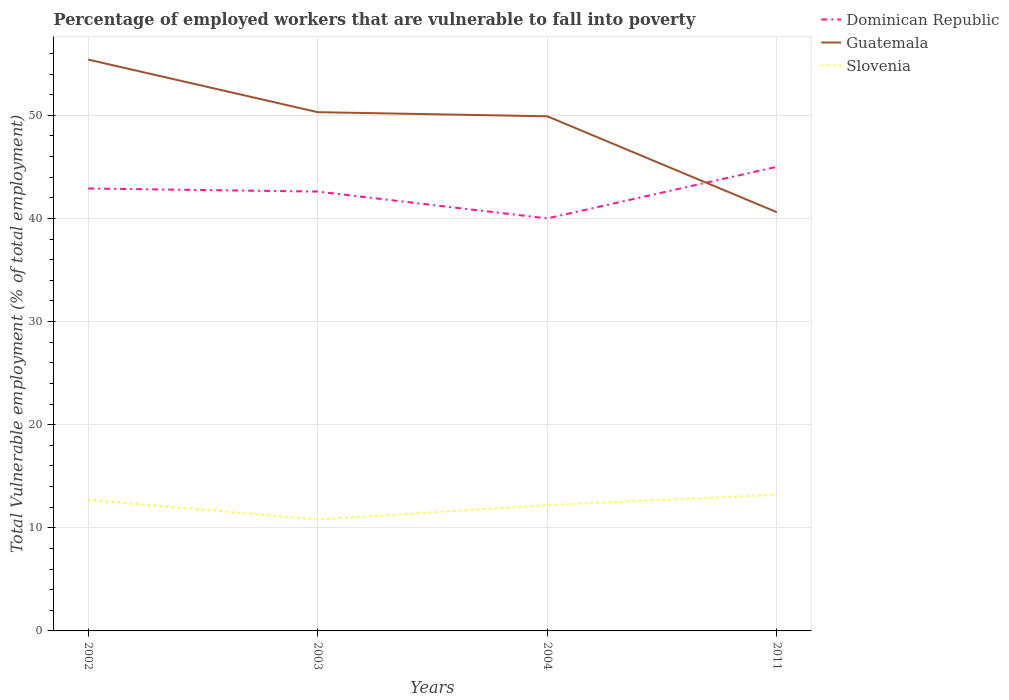Does the line corresponding to Slovenia intersect with the line corresponding to Guatemala?
Give a very brief answer. No. Is the number of lines equal to the number of legend labels?
Provide a succinct answer. Yes. Across all years, what is the maximum percentage of employed workers who are vulnerable to fall into poverty in Slovenia?
Provide a short and direct response. 10.8. What is the total percentage of employed workers who are vulnerable to fall into poverty in Guatemala in the graph?
Ensure brevity in your answer.  5.1. What is the difference between the highest and the second highest percentage of employed workers who are vulnerable to fall into poverty in Guatemala?
Make the answer very short. 14.8. What is the difference between two consecutive major ticks on the Y-axis?
Your answer should be very brief. 10. Does the graph contain any zero values?
Offer a very short reply. No. Does the graph contain grids?
Your answer should be very brief. Yes. Where does the legend appear in the graph?
Provide a short and direct response. Top right. How many legend labels are there?
Your answer should be compact. 3. How are the legend labels stacked?
Ensure brevity in your answer.  Vertical. What is the title of the graph?
Make the answer very short. Percentage of employed workers that are vulnerable to fall into poverty. Does "Guyana" appear as one of the legend labels in the graph?
Offer a terse response. No. What is the label or title of the X-axis?
Keep it short and to the point. Years. What is the label or title of the Y-axis?
Your response must be concise. Total Vulnerable employment (% of total employment). What is the Total Vulnerable employment (% of total employment) of Dominican Republic in 2002?
Make the answer very short. 42.9. What is the Total Vulnerable employment (% of total employment) of Guatemala in 2002?
Provide a short and direct response. 55.4. What is the Total Vulnerable employment (% of total employment) in Slovenia in 2002?
Ensure brevity in your answer.  12.7. What is the Total Vulnerable employment (% of total employment) in Dominican Republic in 2003?
Provide a short and direct response. 42.6. What is the Total Vulnerable employment (% of total employment) of Guatemala in 2003?
Your answer should be compact. 50.3. What is the Total Vulnerable employment (% of total employment) in Slovenia in 2003?
Offer a terse response. 10.8. What is the Total Vulnerable employment (% of total employment) in Dominican Republic in 2004?
Your answer should be very brief. 40. What is the Total Vulnerable employment (% of total employment) in Guatemala in 2004?
Make the answer very short. 49.9. What is the Total Vulnerable employment (% of total employment) in Slovenia in 2004?
Offer a very short reply. 12.2. What is the Total Vulnerable employment (% of total employment) of Dominican Republic in 2011?
Ensure brevity in your answer.  45. What is the Total Vulnerable employment (% of total employment) of Guatemala in 2011?
Your answer should be very brief. 40.6. What is the Total Vulnerable employment (% of total employment) in Slovenia in 2011?
Your answer should be very brief. 13.2. Across all years, what is the maximum Total Vulnerable employment (% of total employment) of Guatemala?
Ensure brevity in your answer.  55.4. Across all years, what is the maximum Total Vulnerable employment (% of total employment) of Slovenia?
Offer a terse response. 13.2. Across all years, what is the minimum Total Vulnerable employment (% of total employment) of Dominican Republic?
Provide a short and direct response. 40. Across all years, what is the minimum Total Vulnerable employment (% of total employment) in Guatemala?
Your answer should be very brief. 40.6. Across all years, what is the minimum Total Vulnerable employment (% of total employment) in Slovenia?
Ensure brevity in your answer.  10.8. What is the total Total Vulnerable employment (% of total employment) of Dominican Republic in the graph?
Keep it short and to the point. 170.5. What is the total Total Vulnerable employment (% of total employment) in Guatemala in the graph?
Your answer should be very brief. 196.2. What is the total Total Vulnerable employment (% of total employment) of Slovenia in the graph?
Keep it short and to the point. 48.9. What is the difference between the Total Vulnerable employment (% of total employment) in Dominican Republic in 2002 and that in 2003?
Offer a terse response. 0.3. What is the difference between the Total Vulnerable employment (% of total employment) of Guatemala in 2002 and that in 2003?
Provide a short and direct response. 5.1. What is the difference between the Total Vulnerable employment (% of total employment) of Dominican Republic in 2002 and that in 2004?
Provide a succinct answer. 2.9. What is the difference between the Total Vulnerable employment (% of total employment) in Slovenia in 2002 and that in 2004?
Your answer should be compact. 0.5. What is the difference between the Total Vulnerable employment (% of total employment) in Dominican Republic in 2002 and that in 2011?
Ensure brevity in your answer.  -2.1. What is the difference between the Total Vulnerable employment (% of total employment) in Guatemala in 2003 and that in 2004?
Your answer should be very brief. 0.4. What is the difference between the Total Vulnerable employment (% of total employment) of Slovenia in 2003 and that in 2004?
Your response must be concise. -1.4. What is the difference between the Total Vulnerable employment (% of total employment) in Dominican Republic in 2003 and that in 2011?
Keep it short and to the point. -2.4. What is the difference between the Total Vulnerable employment (% of total employment) of Dominican Republic in 2004 and that in 2011?
Provide a short and direct response. -5. What is the difference between the Total Vulnerable employment (% of total employment) in Dominican Republic in 2002 and the Total Vulnerable employment (% of total employment) in Slovenia in 2003?
Offer a very short reply. 32.1. What is the difference between the Total Vulnerable employment (% of total employment) of Guatemala in 2002 and the Total Vulnerable employment (% of total employment) of Slovenia in 2003?
Ensure brevity in your answer.  44.6. What is the difference between the Total Vulnerable employment (% of total employment) in Dominican Republic in 2002 and the Total Vulnerable employment (% of total employment) in Slovenia in 2004?
Keep it short and to the point. 30.7. What is the difference between the Total Vulnerable employment (% of total employment) in Guatemala in 2002 and the Total Vulnerable employment (% of total employment) in Slovenia in 2004?
Give a very brief answer. 43.2. What is the difference between the Total Vulnerable employment (% of total employment) in Dominican Republic in 2002 and the Total Vulnerable employment (% of total employment) in Guatemala in 2011?
Make the answer very short. 2.3. What is the difference between the Total Vulnerable employment (% of total employment) of Dominican Republic in 2002 and the Total Vulnerable employment (% of total employment) of Slovenia in 2011?
Keep it short and to the point. 29.7. What is the difference between the Total Vulnerable employment (% of total employment) in Guatemala in 2002 and the Total Vulnerable employment (% of total employment) in Slovenia in 2011?
Offer a very short reply. 42.2. What is the difference between the Total Vulnerable employment (% of total employment) of Dominican Republic in 2003 and the Total Vulnerable employment (% of total employment) of Guatemala in 2004?
Your response must be concise. -7.3. What is the difference between the Total Vulnerable employment (% of total employment) in Dominican Republic in 2003 and the Total Vulnerable employment (% of total employment) in Slovenia in 2004?
Keep it short and to the point. 30.4. What is the difference between the Total Vulnerable employment (% of total employment) in Guatemala in 2003 and the Total Vulnerable employment (% of total employment) in Slovenia in 2004?
Offer a terse response. 38.1. What is the difference between the Total Vulnerable employment (% of total employment) of Dominican Republic in 2003 and the Total Vulnerable employment (% of total employment) of Slovenia in 2011?
Provide a short and direct response. 29.4. What is the difference between the Total Vulnerable employment (% of total employment) of Guatemala in 2003 and the Total Vulnerable employment (% of total employment) of Slovenia in 2011?
Give a very brief answer. 37.1. What is the difference between the Total Vulnerable employment (% of total employment) of Dominican Republic in 2004 and the Total Vulnerable employment (% of total employment) of Slovenia in 2011?
Offer a very short reply. 26.8. What is the difference between the Total Vulnerable employment (% of total employment) in Guatemala in 2004 and the Total Vulnerable employment (% of total employment) in Slovenia in 2011?
Provide a succinct answer. 36.7. What is the average Total Vulnerable employment (% of total employment) of Dominican Republic per year?
Your answer should be very brief. 42.62. What is the average Total Vulnerable employment (% of total employment) of Guatemala per year?
Make the answer very short. 49.05. What is the average Total Vulnerable employment (% of total employment) in Slovenia per year?
Offer a very short reply. 12.22. In the year 2002, what is the difference between the Total Vulnerable employment (% of total employment) in Dominican Republic and Total Vulnerable employment (% of total employment) in Slovenia?
Your answer should be compact. 30.2. In the year 2002, what is the difference between the Total Vulnerable employment (% of total employment) in Guatemala and Total Vulnerable employment (% of total employment) in Slovenia?
Give a very brief answer. 42.7. In the year 2003, what is the difference between the Total Vulnerable employment (% of total employment) of Dominican Republic and Total Vulnerable employment (% of total employment) of Slovenia?
Provide a succinct answer. 31.8. In the year 2003, what is the difference between the Total Vulnerable employment (% of total employment) in Guatemala and Total Vulnerable employment (% of total employment) in Slovenia?
Provide a succinct answer. 39.5. In the year 2004, what is the difference between the Total Vulnerable employment (% of total employment) in Dominican Republic and Total Vulnerable employment (% of total employment) in Slovenia?
Ensure brevity in your answer.  27.8. In the year 2004, what is the difference between the Total Vulnerable employment (% of total employment) in Guatemala and Total Vulnerable employment (% of total employment) in Slovenia?
Your answer should be compact. 37.7. In the year 2011, what is the difference between the Total Vulnerable employment (% of total employment) in Dominican Republic and Total Vulnerable employment (% of total employment) in Slovenia?
Your response must be concise. 31.8. In the year 2011, what is the difference between the Total Vulnerable employment (% of total employment) in Guatemala and Total Vulnerable employment (% of total employment) in Slovenia?
Provide a succinct answer. 27.4. What is the ratio of the Total Vulnerable employment (% of total employment) in Guatemala in 2002 to that in 2003?
Provide a succinct answer. 1.1. What is the ratio of the Total Vulnerable employment (% of total employment) in Slovenia in 2002 to that in 2003?
Keep it short and to the point. 1.18. What is the ratio of the Total Vulnerable employment (% of total employment) in Dominican Republic in 2002 to that in 2004?
Ensure brevity in your answer.  1.07. What is the ratio of the Total Vulnerable employment (% of total employment) in Guatemala in 2002 to that in 2004?
Give a very brief answer. 1.11. What is the ratio of the Total Vulnerable employment (% of total employment) of Slovenia in 2002 to that in 2004?
Offer a terse response. 1.04. What is the ratio of the Total Vulnerable employment (% of total employment) of Dominican Republic in 2002 to that in 2011?
Ensure brevity in your answer.  0.95. What is the ratio of the Total Vulnerable employment (% of total employment) in Guatemala in 2002 to that in 2011?
Offer a very short reply. 1.36. What is the ratio of the Total Vulnerable employment (% of total employment) of Slovenia in 2002 to that in 2011?
Your answer should be very brief. 0.96. What is the ratio of the Total Vulnerable employment (% of total employment) in Dominican Republic in 2003 to that in 2004?
Provide a short and direct response. 1.06. What is the ratio of the Total Vulnerable employment (% of total employment) in Guatemala in 2003 to that in 2004?
Provide a succinct answer. 1.01. What is the ratio of the Total Vulnerable employment (% of total employment) of Slovenia in 2003 to that in 2004?
Provide a succinct answer. 0.89. What is the ratio of the Total Vulnerable employment (% of total employment) of Dominican Republic in 2003 to that in 2011?
Provide a short and direct response. 0.95. What is the ratio of the Total Vulnerable employment (% of total employment) in Guatemala in 2003 to that in 2011?
Give a very brief answer. 1.24. What is the ratio of the Total Vulnerable employment (% of total employment) in Slovenia in 2003 to that in 2011?
Make the answer very short. 0.82. What is the ratio of the Total Vulnerable employment (% of total employment) in Dominican Republic in 2004 to that in 2011?
Keep it short and to the point. 0.89. What is the ratio of the Total Vulnerable employment (% of total employment) in Guatemala in 2004 to that in 2011?
Your answer should be compact. 1.23. What is the ratio of the Total Vulnerable employment (% of total employment) in Slovenia in 2004 to that in 2011?
Keep it short and to the point. 0.92. What is the difference between the highest and the second highest Total Vulnerable employment (% of total employment) of Dominican Republic?
Your answer should be very brief. 2.1. What is the difference between the highest and the second highest Total Vulnerable employment (% of total employment) of Slovenia?
Your answer should be compact. 0.5. What is the difference between the highest and the lowest Total Vulnerable employment (% of total employment) in Dominican Republic?
Ensure brevity in your answer.  5. What is the difference between the highest and the lowest Total Vulnerable employment (% of total employment) in Guatemala?
Provide a succinct answer. 14.8. 